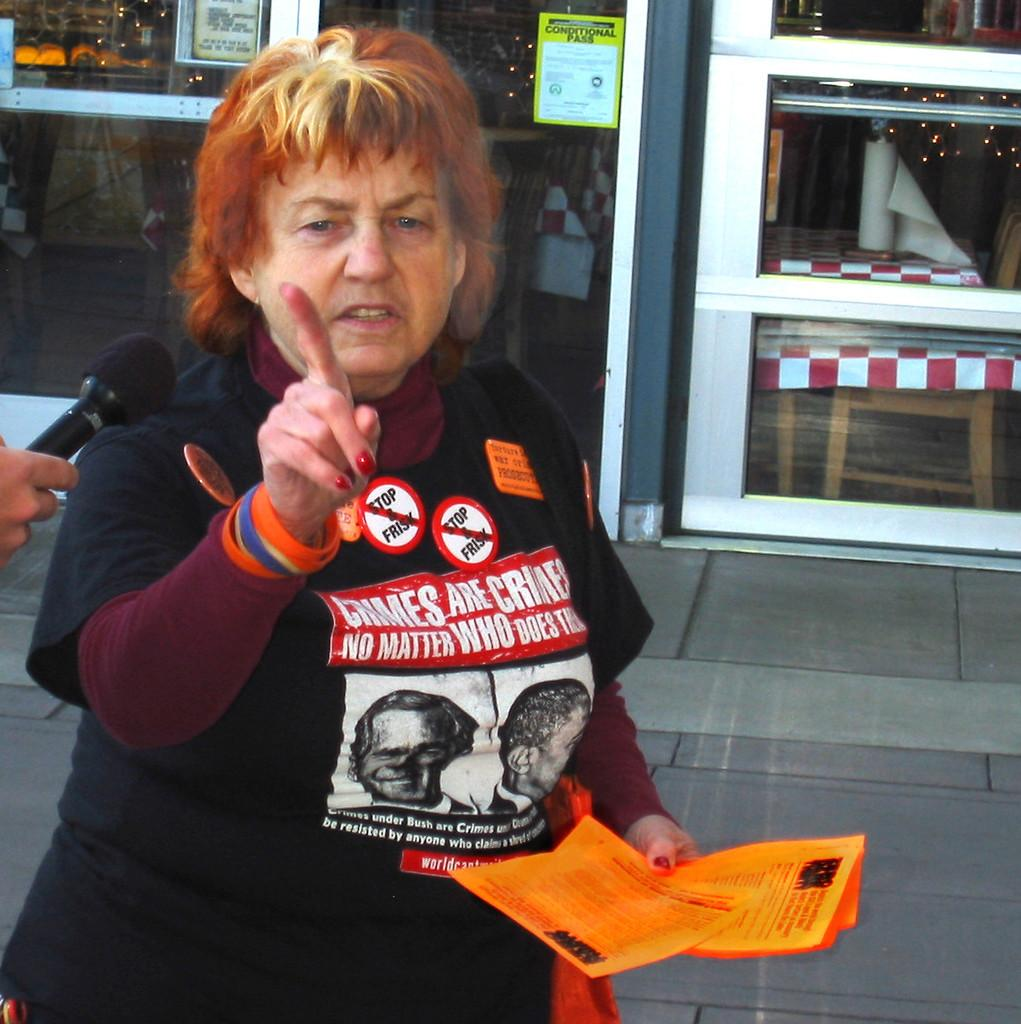Who is present in the image? There is a lady in the image. What is the lady holding in the image? The lady is holding papers. What can be seen on the left side of the image? There is a person's hand holding a mic on the left side of the image. What is visible in the background of the image? There is a door in the background of the image. What type of bait is being used to catch fish in the image? There is no bait or fishing activity present in the image. How does the lady's laughter affect the atmosphere in the image? The lady is not laughing in the image, so it cannot be determined how her laughter would affect the atmosphere. 